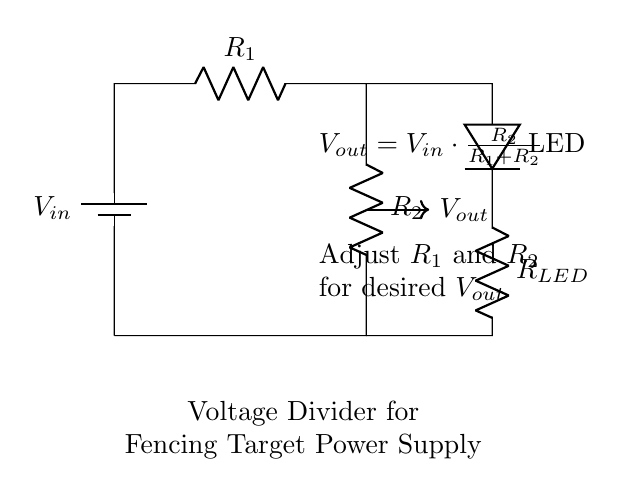What are the resistors in this circuit? The circuit contains two resistors labeled R1 and R2, which are components that create the voltage divider.
Answer: R1, R2 What is the purpose of the LED in this circuit? The LED serves as an indicator that provides visual feedback when the circuit is powered; it lights up when current flows through it.
Answer: Indicator What is the formula for Vout in this circuit? The formula given in the circuit states that Vout is equal to Vin multiplied by the fraction of R2 over the sum of R1 and R2.
Answer: Vout = Vin * (R2 / (R1 + R2)) How does adjusting R1 affect Vout? Increasing R1 decreases the fraction of R2 over (R1 + R2), which in turn lowers Vout, while decreasing R1 has the opposite effect of increasing Vout.
Answer: Decreases Vout What is the relationship between R1 and R2 to achieve a specific Vout? To achieve a desired Vout, R1 and R2 must be adjusted such that their ratio satisfies the voltage divider formula, which defines Vout based on their values.
Answer: Ratio of R2 to R1 and R2 What happens if R2 is much larger than R1? If R2 is significantly larger than R1, Vout approaches Vin because the voltage drop across R1 becomes negligible compared to R2.
Answer: Vout approaches Vin 